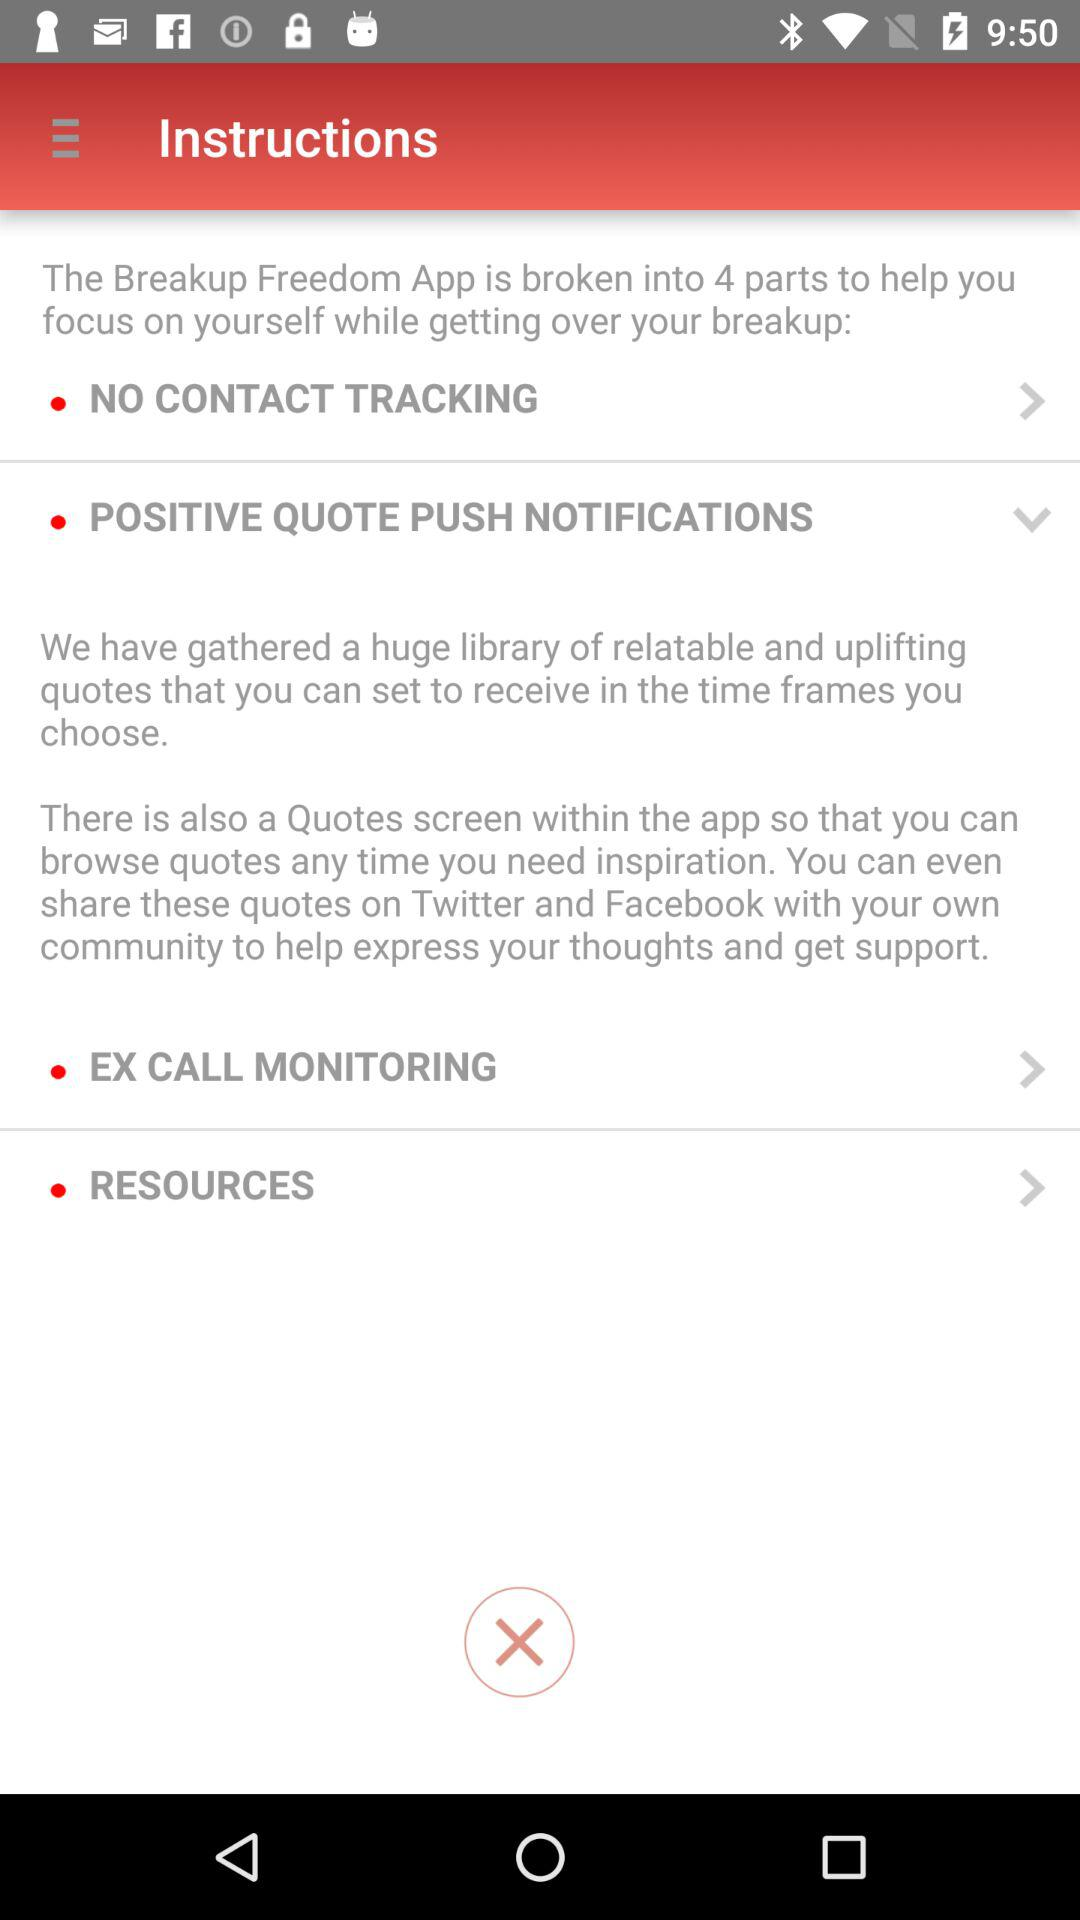Where can the positive quotes be shared? The positive quotes can be shared on "Twitter" and "Facebook". 